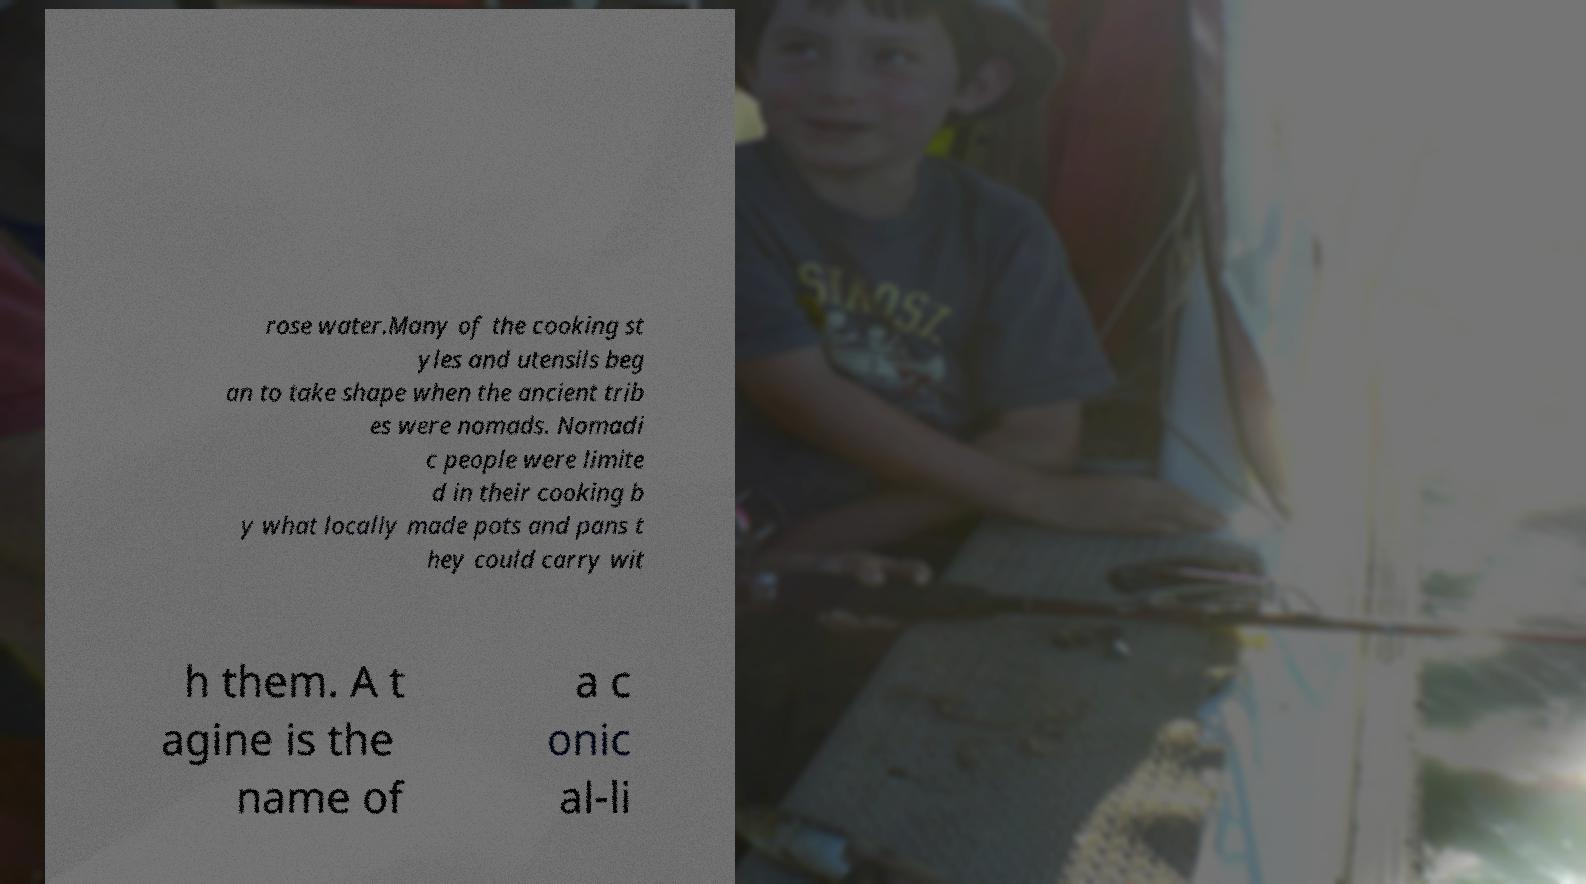Please identify and transcribe the text found in this image. rose water.Many of the cooking st yles and utensils beg an to take shape when the ancient trib es were nomads. Nomadi c people were limite d in their cooking b y what locally made pots and pans t hey could carry wit h them. A t agine is the name of a c onic al-li 